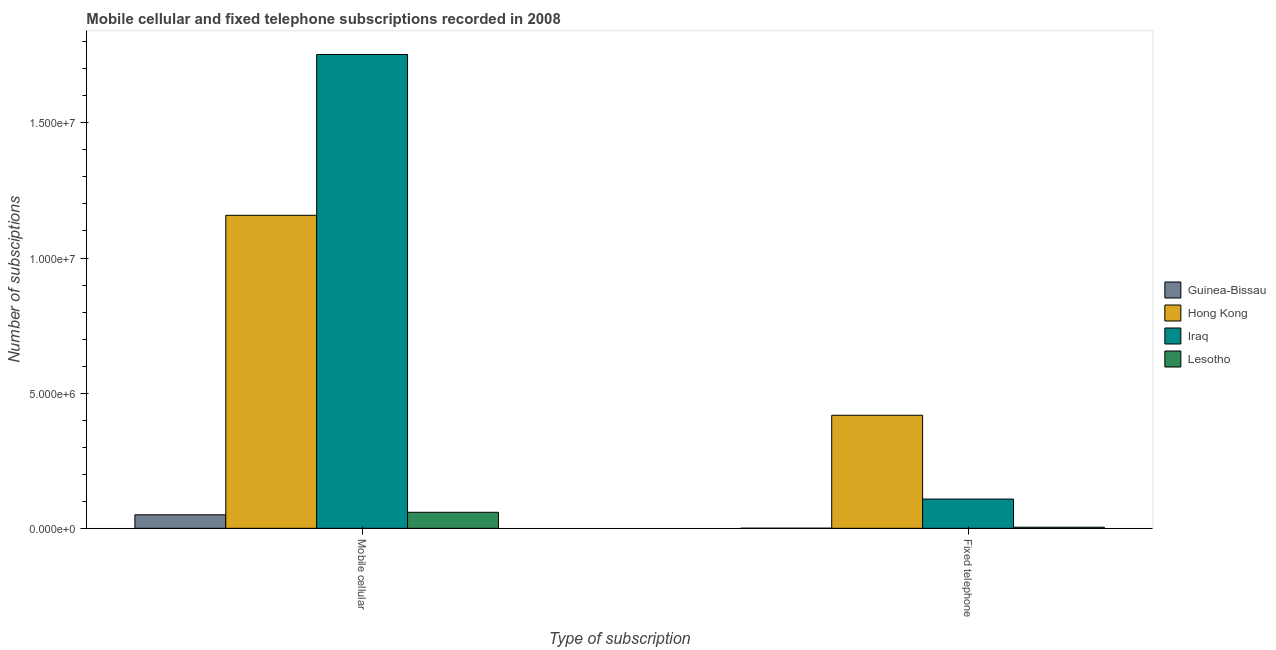Are the number of bars per tick equal to the number of legend labels?
Offer a very short reply. Yes. Are the number of bars on each tick of the X-axis equal?
Your response must be concise. Yes. How many bars are there on the 2nd tick from the right?
Your answer should be very brief. 4. What is the label of the 2nd group of bars from the left?
Ensure brevity in your answer.  Fixed telephone. What is the number of fixed telephone subscriptions in Hong Kong?
Ensure brevity in your answer.  4.18e+06. Across all countries, what is the maximum number of mobile cellular subscriptions?
Provide a succinct answer. 1.75e+07. Across all countries, what is the minimum number of mobile cellular subscriptions?
Offer a terse response. 5.00e+05. In which country was the number of mobile cellular subscriptions maximum?
Ensure brevity in your answer.  Iraq. In which country was the number of fixed telephone subscriptions minimum?
Make the answer very short. Guinea-Bissau. What is the total number of mobile cellular subscriptions in the graph?
Give a very brief answer. 3.02e+07. What is the difference between the number of mobile cellular subscriptions in Hong Kong and that in Guinea-Bissau?
Give a very brief answer. 1.11e+07. What is the difference between the number of mobile cellular subscriptions in Iraq and the number of fixed telephone subscriptions in Lesotho?
Your answer should be very brief. 1.75e+07. What is the average number of mobile cellular subscriptions per country?
Keep it short and to the point. 7.55e+06. What is the difference between the number of fixed telephone subscriptions and number of mobile cellular subscriptions in Iraq?
Ensure brevity in your answer.  -1.64e+07. In how many countries, is the number of mobile cellular subscriptions greater than 14000000 ?
Offer a very short reply. 1. What is the ratio of the number of fixed telephone subscriptions in Lesotho to that in Guinea-Bissau?
Your answer should be compact. 8.86. Is the number of fixed telephone subscriptions in Guinea-Bissau less than that in Lesotho?
Ensure brevity in your answer.  Yes. What does the 2nd bar from the left in Mobile cellular represents?
Offer a terse response. Hong Kong. What does the 1st bar from the right in Mobile cellular represents?
Ensure brevity in your answer.  Lesotho. Are all the bars in the graph horizontal?
Make the answer very short. No. How many countries are there in the graph?
Ensure brevity in your answer.  4. What is the difference between two consecutive major ticks on the Y-axis?
Offer a terse response. 5.00e+06. Are the values on the major ticks of Y-axis written in scientific E-notation?
Give a very brief answer. Yes. Does the graph contain any zero values?
Make the answer very short. No. Does the graph contain grids?
Keep it short and to the point. No. Where does the legend appear in the graph?
Offer a very short reply. Center right. How many legend labels are there?
Your answer should be compact. 4. What is the title of the graph?
Provide a succinct answer. Mobile cellular and fixed telephone subscriptions recorded in 2008. What is the label or title of the X-axis?
Your answer should be compact. Type of subscription. What is the label or title of the Y-axis?
Your response must be concise. Number of subsciptions. What is the Number of subsciptions in Guinea-Bissau in Mobile cellular?
Your answer should be compact. 5.00e+05. What is the Number of subsciptions in Hong Kong in Mobile cellular?
Give a very brief answer. 1.16e+07. What is the Number of subsciptions of Iraq in Mobile cellular?
Ensure brevity in your answer.  1.75e+07. What is the Number of subsciptions in Lesotho in Mobile cellular?
Provide a short and direct response. 5.93e+05. What is the Number of subsciptions of Guinea-Bissau in Fixed telephone?
Provide a succinct answer. 4647. What is the Number of subsciptions in Hong Kong in Fixed telephone?
Your answer should be compact. 4.18e+06. What is the Number of subsciptions of Iraq in Fixed telephone?
Give a very brief answer. 1.08e+06. What is the Number of subsciptions in Lesotho in Fixed telephone?
Provide a short and direct response. 4.12e+04. Across all Type of subscription, what is the maximum Number of subsciptions of Guinea-Bissau?
Provide a succinct answer. 5.00e+05. Across all Type of subscription, what is the maximum Number of subsciptions in Hong Kong?
Offer a terse response. 1.16e+07. Across all Type of subscription, what is the maximum Number of subsciptions of Iraq?
Your response must be concise. 1.75e+07. Across all Type of subscription, what is the maximum Number of subsciptions of Lesotho?
Give a very brief answer. 5.93e+05. Across all Type of subscription, what is the minimum Number of subsciptions of Guinea-Bissau?
Provide a succinct answer. 4647. Across all Type of subscription, what is the minimum Number of subsciptions of Hong Kong?
Your response must be concise. 4.18e+06. Across all Type of subscription, what is the minimum Number of subsciptions of Iraq?
Offer a terse response. 1.08e+06. Across all Type of subscription, what is the minimum Number of subsciptions in Lesotho?
Offer a terse response. 4.12e+04. What is the total Number of subsciptions in Guinea-Bissau in the graph?
Make the answer very short. 5.05e+05. What is the total Number of subsciptions in Hong Kong in the graph?
Your answer should be compact. 1.58e+07. What is the total Number of subsciptions in Iraq in the graph?
Ensure brevity in your answer.  1.86e+07. What is the total Number of subsciptions of Lesotho in the graph?
Provide a succinct answer. 6.34e+05. What is the difference between the Number of subsciptions in Guinea-Bissau in Mobile cellular and that in Fixed telephone?
Provide a short and direct response. 4.96e+05. What is the difference between the Number of subsciptions in Hong Kong in Mobile cellular and that in Fixed telephone?
Offer a terse response. 7.40e+06. What is the difference between the Number of subsciptions in Iraq in Mobile cellular and that in Fixed telephone?
Ensure brevity in your answer.  1.64e+07. What is the difference between the Number of subsciptions in Lesotho in Mobile cellular and that in Fixed telephone?
Provide a succinct answer. 5.52e+05. What is the difference between the Number of subsciptions in Guinea-Bissau in Mobile cellular and the Number of subsciptions in Hong Kong in Fixed telephone?
Your response must be concise. -3.68e+06. What is the difference between the Number of subsciptions of Guinea-Bissau in Mobile cellular and the Number of subsciptions of Iraq in Fixed telephone?
Your response must be concise. -5.82e+05. What is the difference between the Number of subsciptions of Guinea-Bissau in Mobile cellular and the Number of subsciptions of Lesotho in Fixed telephone?
Offer a very short reply. 4.59e+05. What is the difference between the Number of subsciptions in Hong Kong in Mobile cellular and the Number of subsciptions in Iraq in Fixed telephone?
Your response must be concise. 1.05e+07. What is the difference between the Number of subsciptions in Hong Kong in Mobile cellular and the Number of subsciptions in Lesotho in Fixed telephone?
Your answer should be compact. 1.15e+07. What is the difference between the Number of subsciptions of Iraq in Mobile cellular and the Number of subsciptions of Lesotho in Fixed telephone?
Ensure brevity in your answer.  1.75e+07. What is the average Number of subsciptions of Guinea-Bissau per Type of subscription?
Your answer should be very brief. 2.52e+05. What is the average Number of subsciptions in Hong Kong per Type of subscription?
Your response must be concise. 7.88e+06. What is the average Number of subsciptions in Iraq per Type of subscription?
Your response must be concise. 9.31e+06. What is the average Number of subsciptions in Lesotho per Type of subscription?
Provide a short and direct response. 3.17e+05. What is the difference between the Number of subsciptions in Guinea-Bissau and Number of subsciptions in Hong Kong in Mobile cellular?
Ensure brevity in your answer.  -1.11e+07. What is the difference between the Number of subsciptions in Guinea-Bissau and Number of subsciptions in Iraq in Mobile cellular?
Your response must be concise. -1.70e+07. What is the difference between the Number of subsciptions in Guinea-Bissau and Number of subsciptions in Lesotho in Mobile cellular?
Make the answer very short. -9.31e+04. What is the difference between the Number of subsciptions in Hong Kong and Number of subsciptions in Iraq in Mobile cellular?
Offer a terse response. -5.95e+06. What is the difference between the Number of subsciptions of Hong Kong and Number of subsciptions of Lesotho in Mobile cellular?
Make the answer very short. 1.10e+07. What is the difference between the Number of subsciptions of Iraq and Number of subsciptions of Lesotho in Mobile cellular?
Make the answer very short. 1.69e+07. What is the difference between the Number of subsciptions in Guinea-Bissau and Number of subsciptions in Hong Kong in Fixed telephone?
Your answer should be very brief. -4.18e+06. What is the difference between the Number of subsciptions of Guinea-Bissau and Number of subsciptions of Iraq in Fixed telephone?
Your answer should be very brief. -1.08e+06. What is the difference between the Number of subsciptions in Guinea-Bissau and Number of subsciptions in Lesotho in Fixed telephone?
Provide a short and direct response. -3.65e+04. What is the difference between the Number of subsciptions in Hong Kong and Number of subsciptions in Iraq in Fixed telephone?
Provide a succinct answer. 3.10e+06. What is the difference between the Number of subsciptions in Hong Kong and Number of subsciptions in Lesotho in Fixed telephone?
Make the answer very short. 4.14e+06. What is the difference between the Number of subsciptions in Iraq and Number of subsciptions in Lesotho in Fixed telephone?
Provide a succinct answer. 1.04e+06. What is the ratio of the Number of subsciptions in Guinea-Bissau in Mobile cellular to that in Fixed telephone?
Keep it short and to the point. 107.63. What is the ratio of the Number of subsciptions of Hong Kong in Mobile cellular to that in Fixed telephone?
Offer a terse response. 2.77. What is the ratio of the Number of subsciptions in Iraq in Mobile cellular to that in Fixed telephone?
Make the answer very short. 16.2. What is the ratio of the Number of subsciptions of Lesotho in Mobile cellular to that in Fixed telephone?
Make the answer very short. 14.4. What is the difference between the highest and the second highest Number of subsciptions of Guinea-Bissau?
Offer a terse response. 4.96e+05. What is the difference between the highest and the second highest Number of subsciptions in Hong Kong?
Give a very brief answer. 7.40e+06. What is the difference between the highest and the second highest Number of subsciptions in Iraq?
Provide a succinct answer. 1.64e+07. What is the difference between the highest and the second highest Number of subsciptions in Lesotho?
Ensure brevity in your answer.  5.52e+05. What is the difference between the highest and the lowest Number of subsciptions in Guinea-Bissau?
Your answer should be very brief. 4.96e+05. What is the difference between the highest and the lowest Number of subsciptions in Hong Kong?
Provide a succinct answer. 7.40e+06. What is the difference between the highest and the lowest Number of subsciptions of Iraq?
Give a very brief answer. 1.64e+07. What is the difference between the highest and the lowest Number of subsciptions of Lesotho?
Your answer should be very brief. 5.52e+05. 